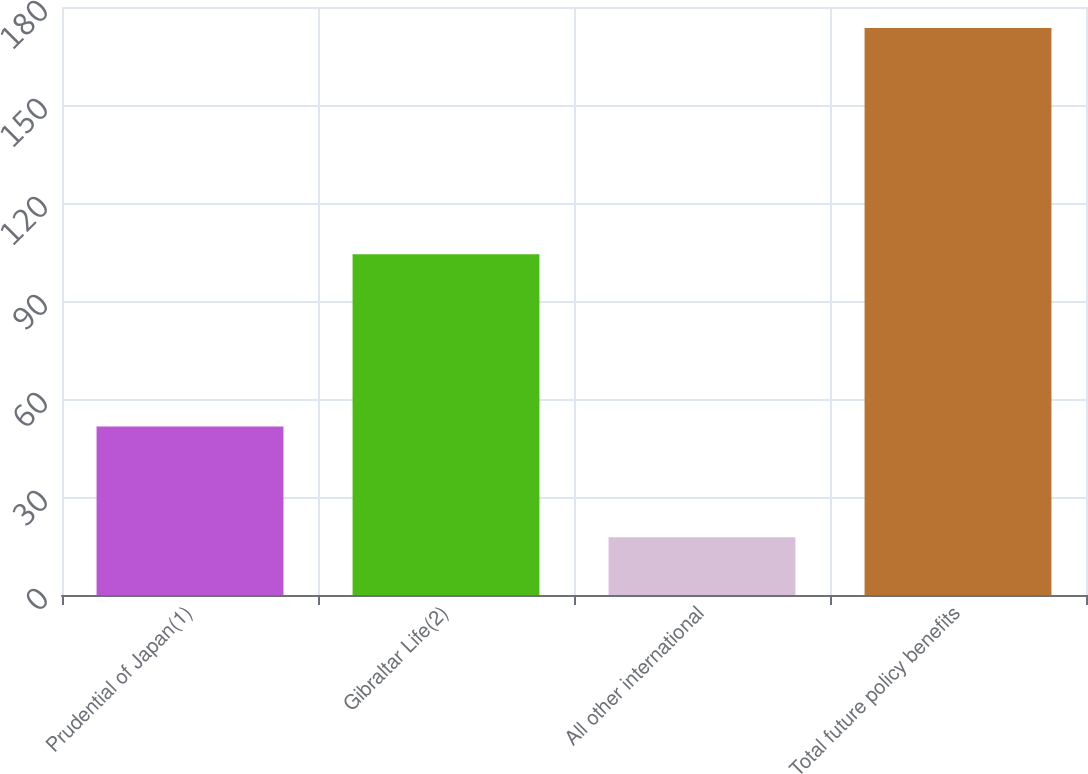Convert chart. <chart><loc_0><loc_0><loc_500><loc_500><bar_chart><fcel>Prudential of Japan(1)<fcel>Gibraltar Life(2)<fcel>All other international<fcel>Total future policy benefits<nl><fcel>51.6<fcel>104.3<fcel>17.7<fcel>173.6<nl></chart> 